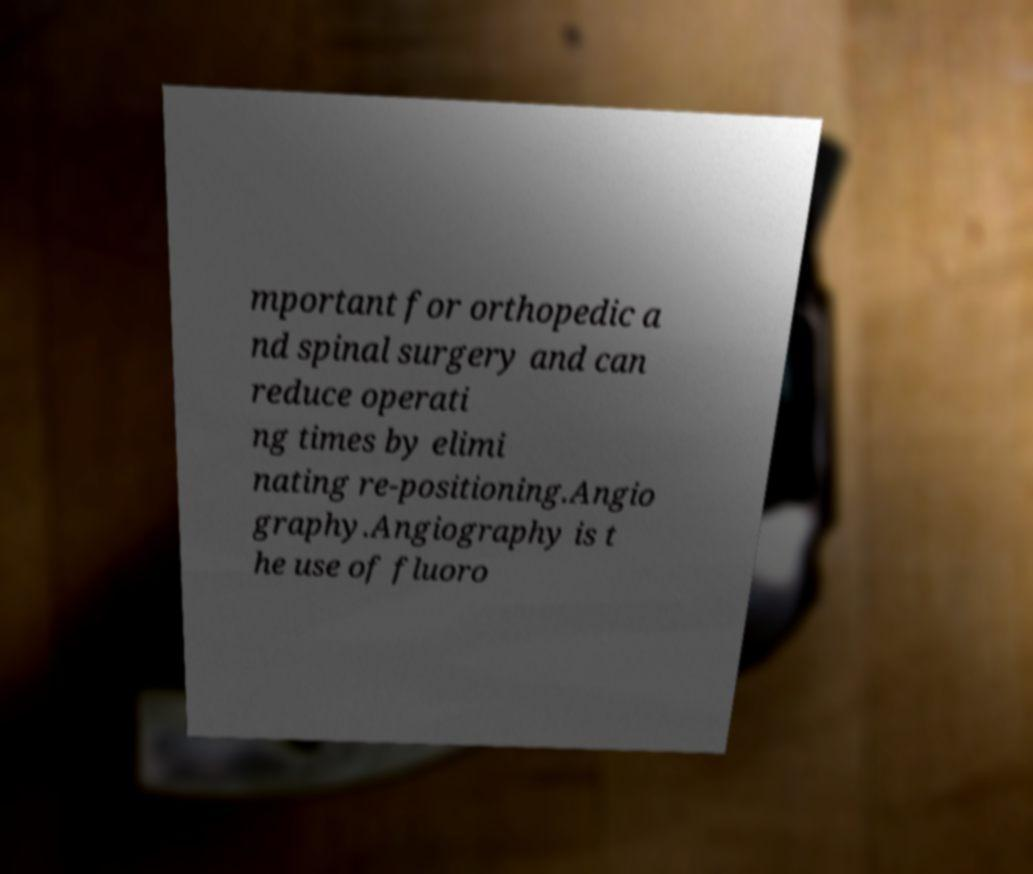Can you read and provide the text displayed in the image?This photo seems to have some interesting text. Can you extract and type it out for me? mportant for orthopedic a nd spinal surgery and can reduce operati ng times by elimi nating re-positioning.Angio graphy.Angiography is t he use of fluoro 